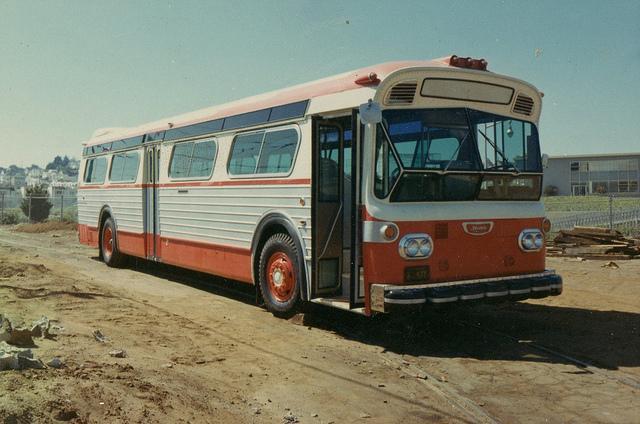How many terminals are shown in the picture?
Give a very brief answer. 0. 